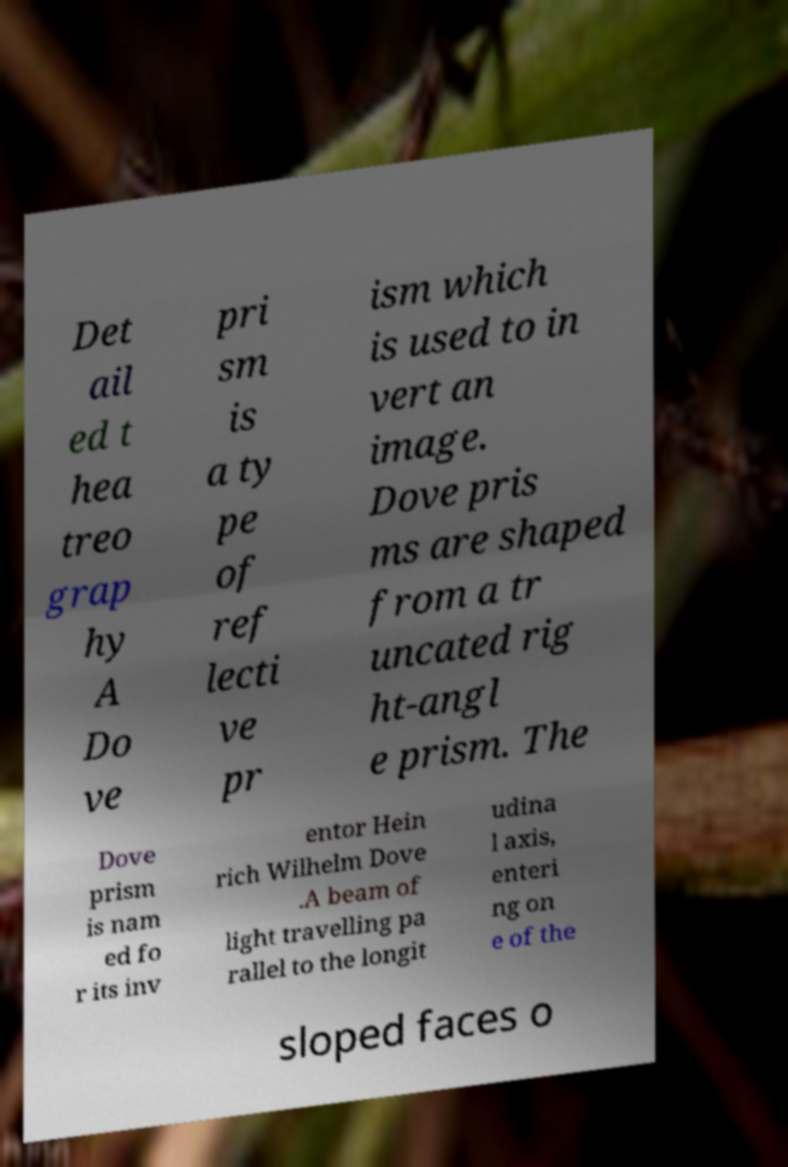Could you extract and type out the text from this image? Det ail ed t hea treo grap hy A Do ve pri sm is a ty pe of ref lecti ve pr ism which is used to in vert an image. Dove pris ms are shaped from a tr uncated rig ht-angl e prism. The Dove prism is nam ed fo r its inv entor Hein rich Wilhelm Dove .A beam of light travelling pa rallel to the longit udina l axis, enteri ng on e of the sloped faces o 